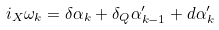<formula> <loc_0><loc_0><loc_500><loc_500>i _ { X } \omega _ { k } = \delta \alpha _ { k } + \delta _ { Q } \alpha ^ { \prime } _ { k - 1 } + d \alpha ^ { \prime } _ { k }</formula> 